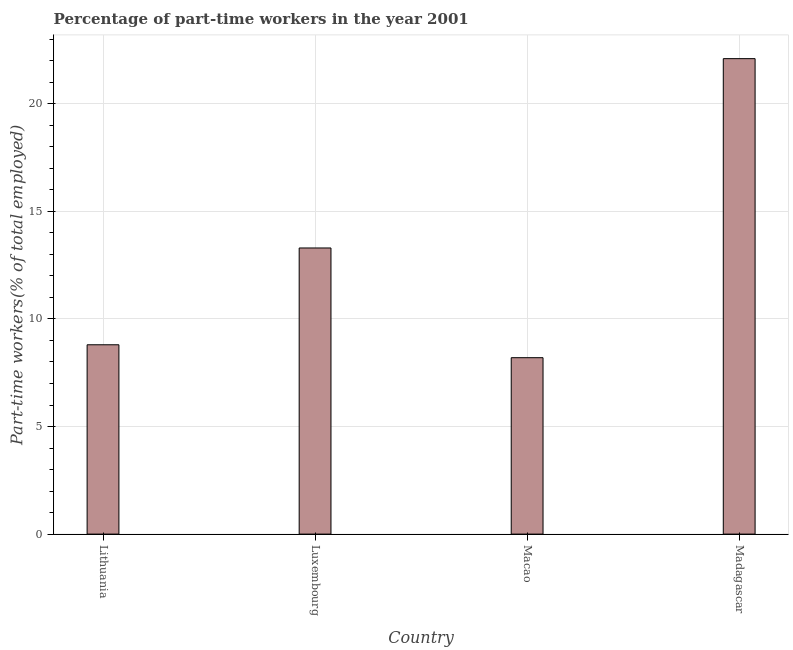What is the title of the graph?
Your answer should be compact. Percentage of part-time workers in the year 2001. What is the label or title of the X-axis?
Your answer should be compact. Country. What is the label or title of the Y-axis?
Your answer should be very brief. Part-time workers(% of total employed). What is the percentage of part-time workers in Madagascar?
Make the answer very short. 22.1. Across all countries, what is the maximum percentage of part-time workers?
Keep it short and to the point. 22.1. Across all countries, what is the minimum percentage of part-time workers?
Your answer should be compact. 8.2. In which country was the percentage of part-time workers maximum?
Provide a succinct answer. Madagascar. In which country was the percentage of part-time workers minimum?
Provide a short and direct response. Macao. What is the sum of the percentage of part-time workers?
Your answer should be compact. 52.4. What is the average percentage of part-time workers per country?
Give a very brief answer. 13.1. What is the median percentage of part-time workers?
Your answer should be very brief. 11.05. What is the ratio of the percentage of part-time workers in Lithuania to that in Madagascar?
Your response must be concise. 0.4. Is the difference between the percentage of part-time workers in Luxembourg and Macao greater than the difference between any two countries?
Ensure brevity in your answer.  No. What is the difference between the highest and the second highest percentage of part-time workers?
Your answer should be compact. 8.8. Is the sum of the percentage of part-time workers in Lithuania and Luxembourg greater than the maximum percentage of part-time workers across all countries?
Provide a short and direct response. Yes. What is the Part-time workers(% of total employed) of Lithuania?
Give a very brief answer. 8.8. What is the Part-time workers(% of total employed) of Luxembourg?
Offer a very short reply. 13.3. What is the Part-time workers(% of total employed) in Macao?
Your response must be concise. 8.2. What is the Part-time workers(% of total employed) of Madagascar?
Offer a terse response. 22.1. What is the difference between the Part-time workers(% of total employed) in Lithuania and Madagascar?
Keep it short and to the point. -13.3. What is the difference between the Part-time workers(% of total employed) in Luxembourg and Madagascar?
Ensure brevity in your answer.  -8.8. What is the ratio of the Part-time workers(% of total employed) in Lithuania to that in Luxembourg?
Your answer should be very brief. 0.66. What is the ratio of the Part-time workers(% of total employed) in Lithuania to that in Macao?
Offer a terse response. 1.07. What is the ratio of the Part-time workers(% of total employed) in Lithuania to that in Madagascar?
Provide a short and direct response. 0.4. What is the ratio of the Part-time workers(% of total employed) in Luxembourg to that in Macao?
Give a very brief answer. 1.62. What is the ratio of the Part-time workers(% of total employed) in Luxembourg to that in Madagascar?
Your answer should be very brief. 0.6. What is the ratio of the Part-time workers(% of total employed) in Macao to that in Madagascar?
Make the answer very short. 0.37. 